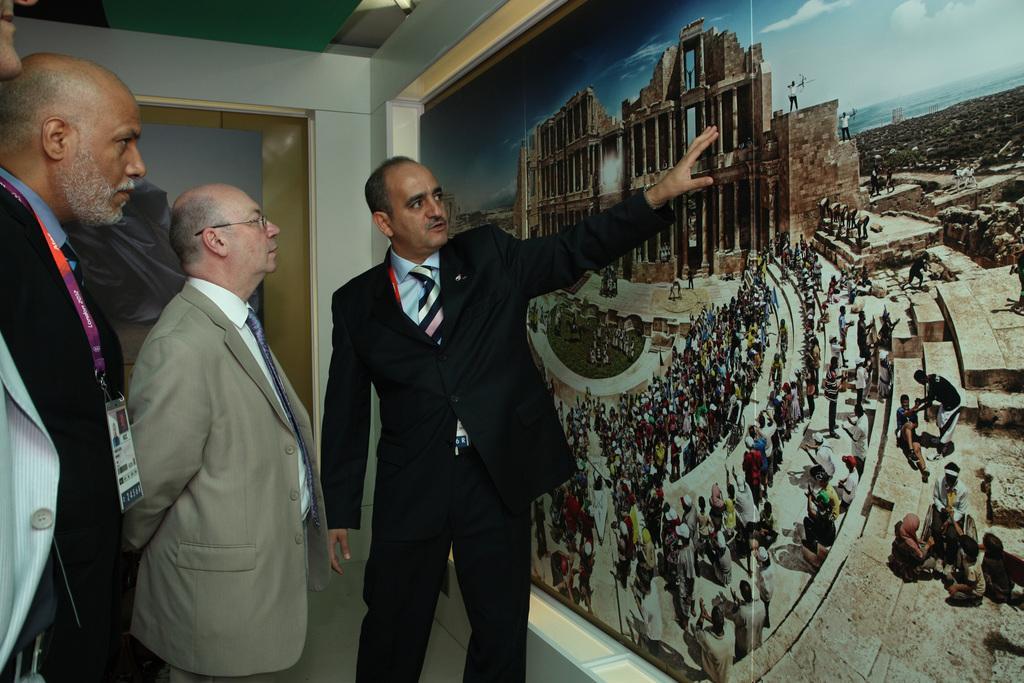Can you describe this image briefly? In this image I can see four persons standing. The person in front wearing black blazer, blue shirt, black and white tie, left I can see a frame attached to the wall and the wall is in white color. 